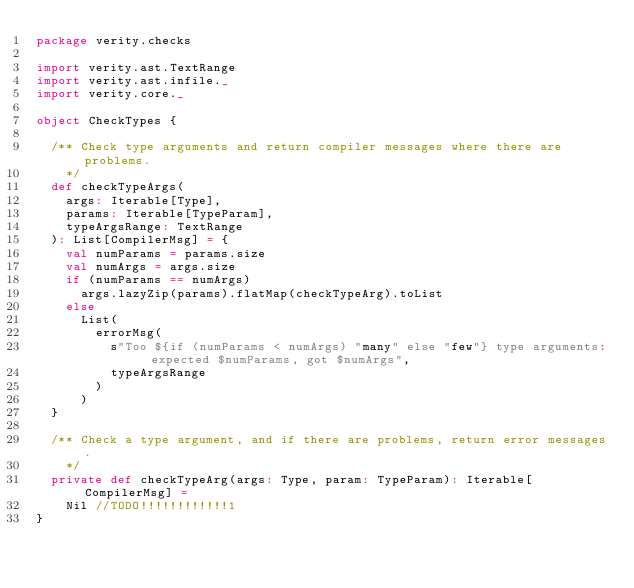<code> <loc_0><loc_0><loc_500><loc_500><_Scala_>package verity.checks

import verity.ast.TextRange
import verity.ast.infile._
import verity.core._

object CheckTypes {

  /** Check type arguments and return compiler messages where there are problems.
    */
  def checkTypeArgs(
    args: Iterable[Type],
    params: Iterable[TypeParam],
    typeArgsRange: TextRange
  ): List[CompilerMsg] = {
    val numParams = params.size
    val numArgs = args.size
    if (numParams == numArgs)
      args.lazyZip(params).flatMap(checkTypeArg).toList
    else
      List(
        errorMsg(
          s"Too ${if (numParams < numArgs) "many" else "few"} type arguments: expected $numParams, got $numArgs",
          typeArgsRange
        )
      )
  }

  /** Check a type argument, and if there are problems, return error messages.
    */
  private def checkTypeArg(args: Type, param: TypeParam): Iterable[CompilerMsg] =
    Nil //TODO!!!!!!!!!!!!1
}
</code> 